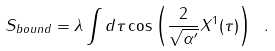Convert formula to latex. <formula><loc_0><loc_0><loc_500><loc_500>S _ { b o u n d } = \lambda \int d \tau \cos \left ( \frac { 2 } { \sqrt { \alpha ^ { \prime } } } X ^ { 1 } ( \tau ) \right ) \ .</formula> 